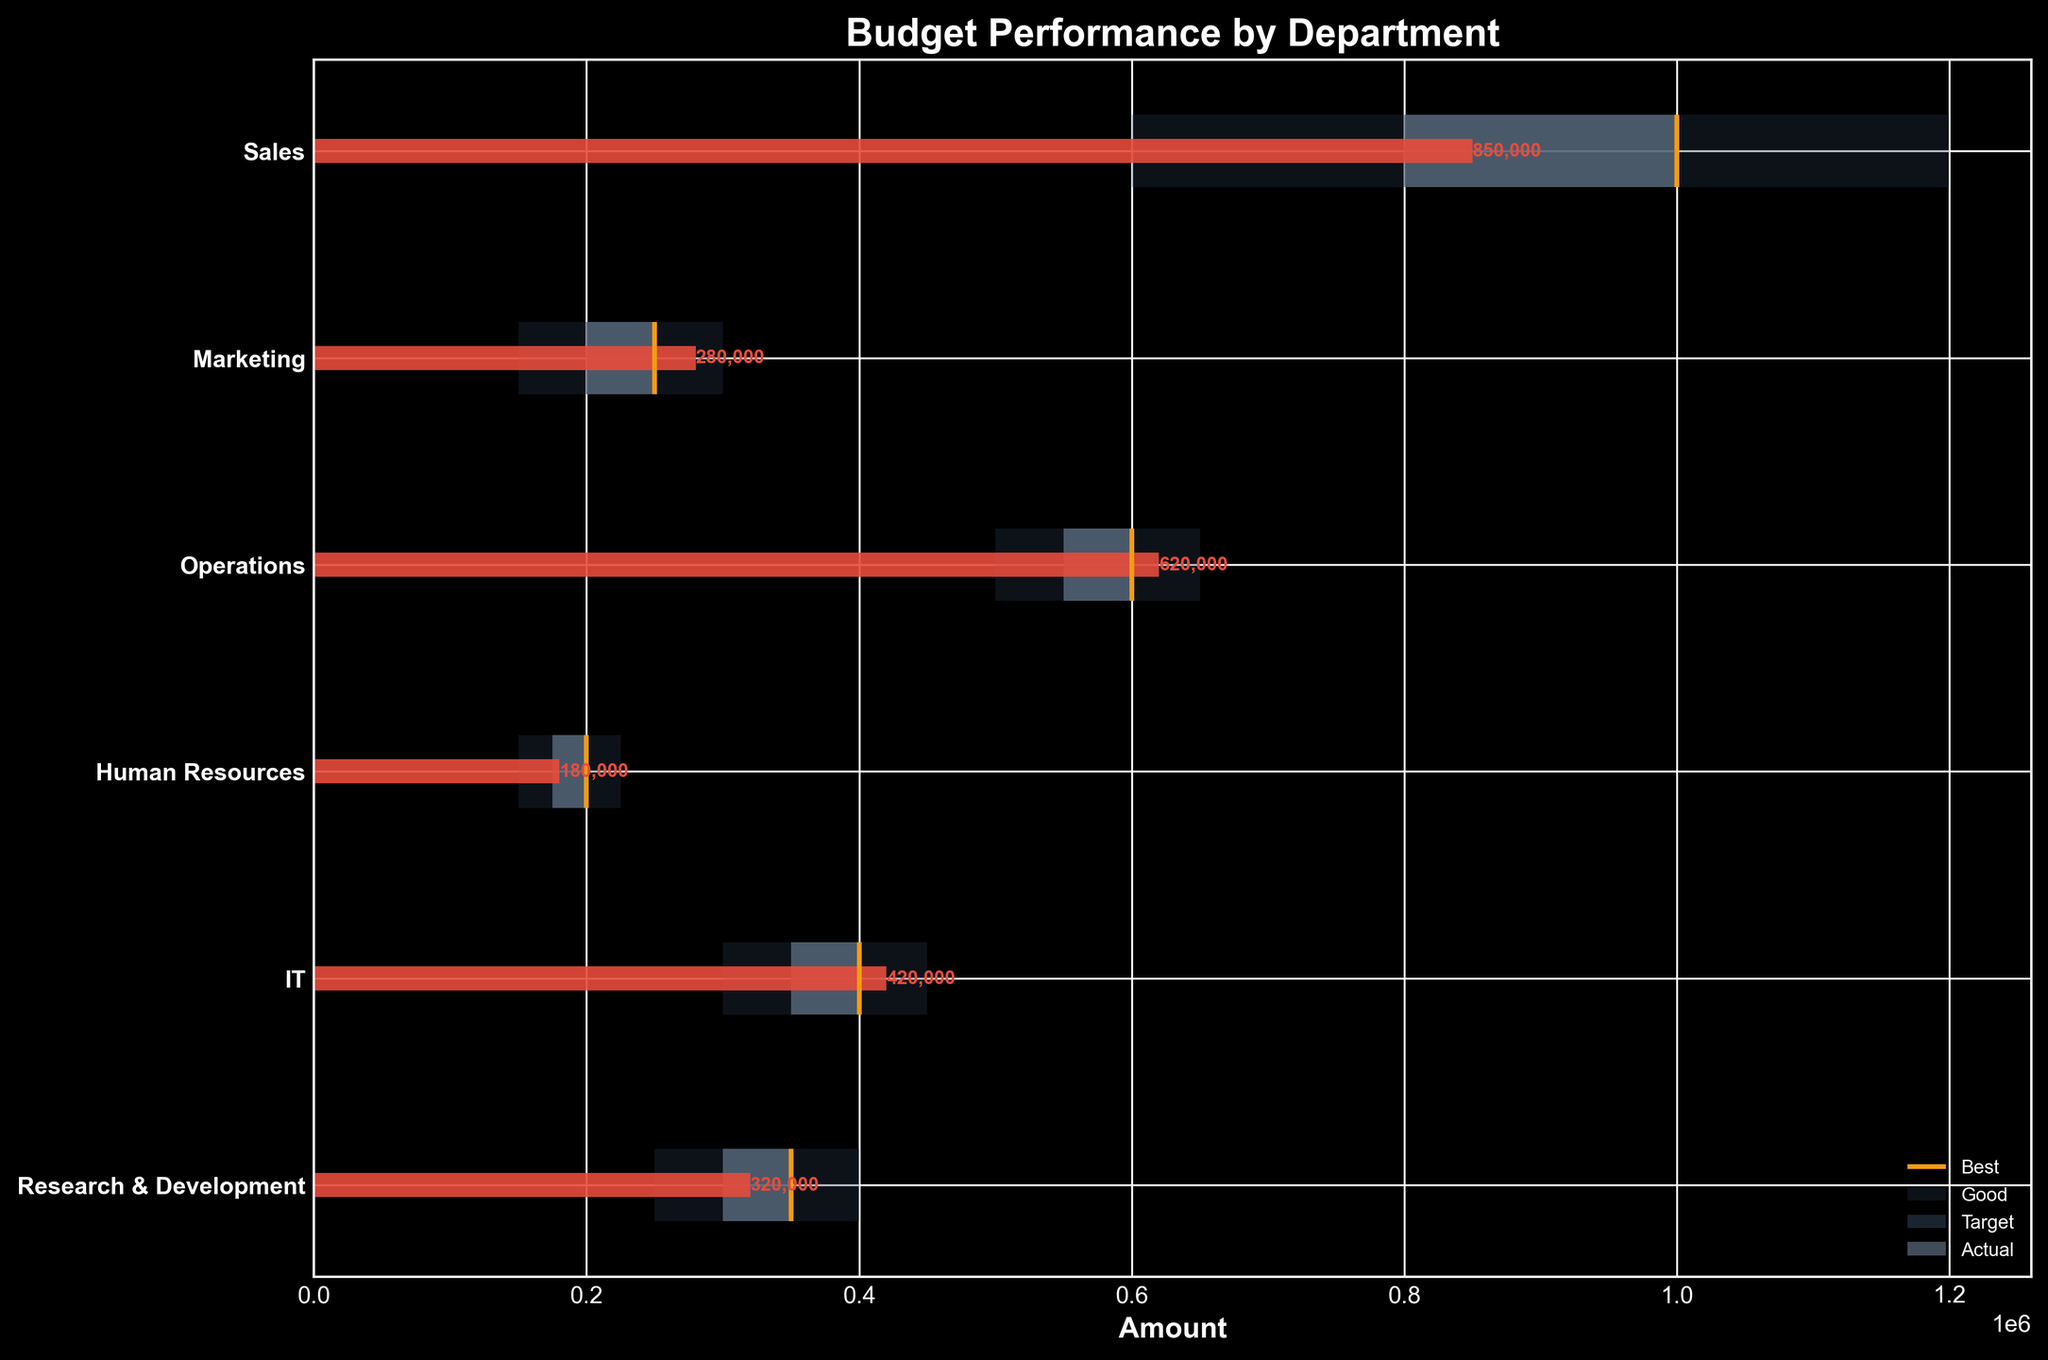What is the title of the chart? The title of the chart is typically located at the top, above all other elements. In this case, it should be clearly stated.
Answer: Budget Performance by Department Which department has the highest actual value? To find the department with the highest actual value, inspect all the red bars in the chart and identify the one that extends the furthest to the right.
Answer: Sales What is the actual value for the Marketing department? Look at the red bar corresponding to the Marketing department and read the numerical label at its end.
Answer: 280,000 How does the actual value for the IT department compare to its target value? Identify the target line for the IT department and compare it to the actual red bar for IT. The target is 400,000 and the actual value is 420,000. The actual value is greater than the target.
Answer: Greater than the target Which department fell short of its target by the greatest amount? Calculate the difference between the target and actual value for each department. The department with the largest negative difference is the one that fell short by the greatest amount.
Answer: Sales What range is considered 'good' for the Research & Development department? Refer to the part of the bar for Research & Development labelled 'Good'. It's the portion between 300,000 and 350,000.
Answer: 300,000 to 350,000 Did the Human Resources department meet its 'best' performance level? Compare the actual value of Human Resources to its 'best' range. The best range starts at 200,000 and goes to 225,000, and the actual value is 180,000. It did not meet the 'best' level.
Answer: No Which departments exceeded their targets? Observe the red bars (actual values) and the orange lines (targets). Departments where the red bar extends beyond the orange line have exceeded their targets.
Answer: Marketing, Operations, IT What is the difference between the best and worst performance levels for the Sales department? Subtract the worst performance value from the best performance value for the Sales department. The best performance is 1,200,000 and the worst is 600,000.
Answer: 600,000 Which department has the smallest gap between its actual and target values? Calculate the absolute differences between actual and target values for all departments. The one with the smallest gap is the department with the smallest absolute difference.
Answer: Operations 